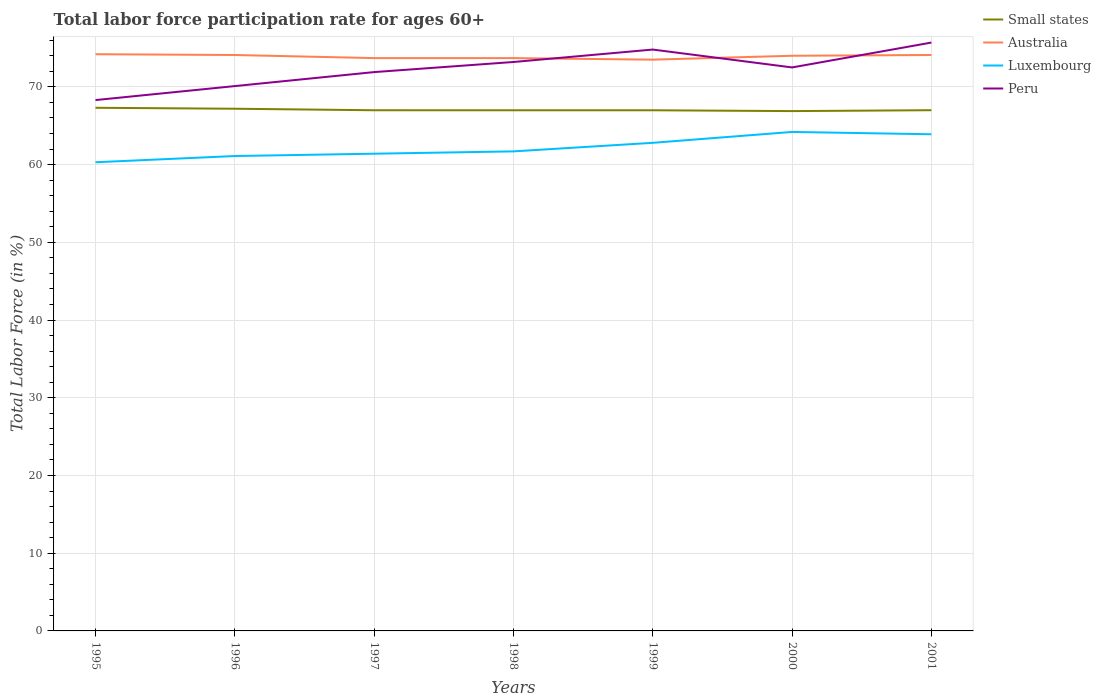Across all years, what is the maximum labor force participation rate in Luxembourg?
Give a very brief answer. 60.3. What is the total labor force participation rate in Peru in the graph?
Make the answer very short. -0.9. What is the difference between the highest and the second highest labor force participation rate in Luxembourg?
Offer a very short reply. 3.9. What is the difference between the highest and the lowest labor force participation rate in Small states?
Offer a very short reply. 2. Is the labor force participation rate in Luxembourg strictly greater than the labor force participation rate in Peru over the years?
Your answer should be compact. Yes. How many lines are there?
Keep it short and to the point. 4. How many years are there in the graph?
Offer a very short reply. 7. Are the values on the major ticks of Y-axis written in scientific E-notation?
Your answer should be compact. No. Does the graph contain any zero values?
Your answer should be compact. No. Does the graph contain grids?
Your answer should be compact. Yes. Where does the legend appear in the graph?
Make the answer very short. Top right. How many legend labels are there?
Your answer should be very brief. 4. How are the legend labels stacked?
Give a very brief answer. Vertical. What is the title of the graph?
Offer a terse response. Total labor force participation rate for ages 60+. Does "Paraguay" appear as one of the legend labels in the graph?
Your response must be concise. No. What is the Total Labor Force (in %) of Small states in 1995?
Give a very brief answer. 67.31. What is the Total Labor Force (in %) of Australia in 1995?
Your answer should be very brief. 74.2. What is the Total Labor Force (in %) in Luxembourg in 1995?
Give a very brief answer. 60.3. What is the Total Labor Force (in %) of Peru in 1995?
Ensure brevity in your answer.  68.3. What is the Total Labor Force (in %) of Small states in 1996?
Offer a very short reply. 67.19. What is the Total Labor Force (in %) in Australia in 1996?
Offer a terse response. 74.1. What is the Total Labor Force (in %) in Luxembourg in 1996?
Your answer should be very brief. 61.1. What is the Total Labor Force (in %) in Peru in 1996?
Keep it short and to the point. 70.1. What is the Total Labor Force (in %) of Small states in 1997?
Ensure brevity in your answer.  66.99. What is the Total Labor Force (in %) in Australia in 1997?
Keep it short and to the point. 73.7. What is the Total Labor Force (in %) of Luxembourg in 1997?
Give a very brief answer. 61.4. What is the Total Labor Force (in %) in Peru in 1997?
Keep it short and to the point. 71.9. What is the Total Labor Force (in %) of Small states in 1998?
Provide a short and direct response. 66.99. What is the Total Labor Force (in %) in Australia in 1998?
Your response must be concise. 73.7. What is the Total Labor Force (in %) in Luxembourg in 1998?
Ensure brevity in your answer.  61.7. What is the Total Labor Force (in %) in Peru in 1998?
Offer a terse response. 73.2. What is the Total Labor Force (in %) of Small states in 1999?
Make the answer very short. 66.99. What is the Total Labor Force (in %) of Australia in 1999?
Your answer should be very brief. 73.5. What is the Total Labor Force (in %) in Luxembourg in 1999?
Give a very brief answer. 62.8. What is the Total Labor Force (in %) of Peru in 1999?
Make the answer very short. 74.8. What is the Total Labor Force (in %) of Small states in 2000?
Ensure brevity in your answer.  66.88. What is the Total Labor Force (in %) of Luxembourg in 2000?
Give a very brief answer. 64.2. What is the Total Labor Force (in %) of Peru in 2000?
Make the answer very short. 72.5. What is the Total Labor Force (in %) of Small states in 2001?
Your answer should be compact. 67. What is the Total Labor Force (in %) in Australia in 2001?
Your answer should be very brief. 74.1. What is the Total Labor Force (in %) of Luxembourg in 2001?
Your response must be concise. 63.9. What is the Total Labor Force (in %) of Peru in 2001?
Provide a succinct answer. 75.7. Across all years, what is the maximum Total Labor Force (in %) of Small states?
Make the answer very short. 67.31. Across all years, what is the maximum Total Labor Force (in %) in Australia?
Your response must be concise. 74.2. Across all years, what is the maximum Total Labor Force (in %) of Luxembourg?
Ensure brevity in your answer.  64.2. Across all years, what is the maximum Total Labor Force (in %) in Peru?
Give a very brief answer. 75.7. Across all years, what is the minimum Total Labor Force (in %) in Small states?
Ensure brevity in your answer.  66.88. Across all years, what is the minimum Total Labor Force (in %) of Australia?
Your answer should be compact. 73.5. Across all years, what is the minimum Total Labor Force (in %) in Luxembourg?
Offer a terse response. 60.3. Across all years, what is the minimum Total Labor Force (in %) in Peru?
Offer a terse response. 68.3. What is the total Total Labor Force (in %) in Small states in the graph?
Make the answer very short. 469.34. What is the total Total Labor Force (in %) of Australia in the graph?
Provide a succinct answer. 517.3. What is the total Total Labor Force (in %) of Luxembourg in the graph?
Offer a very short reply. 435.4. What is the total Total Labor Force (in %) of Peru in the graph?
Provide a succinct answer. 506.5. What is the difference between the Total Labor Force (in %) in Small states in 1995 and that in 1996?
Offer a terse response. 0.12. What is the difference between the Total Labor Force (in %) of Australia in 1995 and that in 1996?
Provide a succinct answer. 0.1. What is the difference between the Total Labor Force (in %) in Luxembourg in 1995 and that in 1996?
Offer a terse response. -0.8. What is the difference between the Total Labor Force (in %) in Peru in 1995 and that in 1996?
Provide a succinct answer. -1.8. What is the difference between the Total Labor Force (in %) of Small states in 1995 and that in 1997?
Provide a short and direct response. 0.32. What is the difference between the Total Labor Force (in %) of Australia in 1995 and that in 1997?
Offer a terse response. 0.5. What is the difference between the Total Labor Force (in %) of Luxembourg in 1995 and that in 1997?
Your answer should be very brief. -1.1. What is the difference between the Total Labor Force (in %) in Small states in 1995 and that in 1998?
Your response must be concise. 0.32. What is the difference between the Total Labor Force (in %) of Small states in 1995 and that in 1999?
Your response must be concise. 0.32. What is the difference between the Total Labor Force (in %) of Luxembourg in 1995 and that in 1999?
Ensure brevity in your answer.  -2.5. What is the difference between the Total Labor Force (in %) in Small states in 1995 and that in 2000?
Ensure brevity in your answer.  0.43. What is the difference between the Total Labor Force (in %) in Luxembourg in 1995 and that in 2000?
Give a very brief answer. -3.9. What is the difference between the Total Labor Force (in %) in Small states in 1995 and that in 2001?
Your answer should be compact. 0.31. What is the difference between the Total Labor Force (in %) of Australia in 1995 and that in 2001?
Make the answer very short. 0.1. What is the difference between the Total Labor Force (in %) in Luxembourg in 1995 and that in 2001?
Give a very brief answer. -3.6. What is the difference between the Total Labor Force (in %) of Small states in 1996 and that in 1997?
Make the answer very short. 0.2. What is the difference between the Total Labor Force (in %) of Luxembourg in 1996 and that in 1997?
Keep it short and to the point. -0.3. What is the difference between the Total Labor Force (in %) of Peru in 1996 and that in 1997?
Your response must be concise. -1.8. What is the difference between the Total Labor Force (in %) in Small states in 1996 and that in 1998?
Your answer should be very brief. 0.2. What is the difference between the Total Labor Force (in %) in Peru in 1996 and that in 1998?
Offer a terse response. -3.1. What is the difference between the Total Labor Force (in %) of Small states in 1996 and that in 1999?
Your response must be concise. 0.2. What is the difference between the Total Labor Force (in %) in Small states in 1996 and that in 2000?
Give a very brief answer. 0.31. What is the difference between the Total Labor Force (in %) in Small states in 1996 and that in 2001?
Keep it short and to the point. 0.19. What is the difference between the Total Labor Force (in %) of Luxembourg in 1996 and that in 2001?
Keep it short and to the point. -2.8. What is the difference between the Total Labor Force (in %) in Small states in 1997 and that in 1998?
Your response must be concise. 0. What is the difference between the Total Labor Force (in %) of Australia in 1997 and that in 1998?
Ensure brevity in your answer.  0. What is the difference between the Total Labor Force (in %) of Luxembourg in 1997 and that in 1998?
Offer a very short reply. -0.3. What is the difference between the Total Labor Force (in %) of Small states in 1997 and that in 1999?
Make the answer very short. 0. What is the difference between the Total Labor Force (in %) of Australia in 1997 and that in 1999?
Provide a short and direct response. 0.2. What is the difference between the Total Labor Force (in %) in Luxembourg in 1997 and that in 1999?
Offer a terse response. -1.4. What is the difference between the Total Labor Force (in %) in Small states in 1997 and that in 2000?
Your answer should be compact. 0.11. What is the difference between the Total Labor Force (in %) in Australia in 1997 and that in 2000?
Offer a terse response. -0.3. What is the difference between the Total Labor Force (in %) of Peru in 1997 and that in 2000?
Give a very brief answer. -0.6. What is the difference between the Total Labor Force (in %) of Small states in 1997 and that in 2001?
Provide a short and direct response. -0.01. What is the difference between the Total Labor Force (in %) in Australia in 1997 and that in 2001?
Ensure brevity in your answer.  -0.4. What is the difference between the Total Labor Force (in %) in Peru in 1997 and that in 2001?
Your answer should be very brief. -3.8. What is the difference between the Total Labor Force (in %) in Small states in 1998 and that in 1999?
Give a very brief answer. 0. What is the difference between the Total Labor Force (in %) of Luxembourg in 1998 and that in 1999?
Your answer should be compact. -1.1. What is the difference between the Total Labor Force (in %) in Small states in 1998 and that in 2000?
Your answer should be compact. 0.11. What is the difference between the Total Labor Force (in %) of Peru in 1998 and that in 2000?
Provide a succinct answer. 0.7. What is the difference between the Total Labor Force (in %) of Small states in 1998 and that in 2001?
Ensure brevity in your answer.  -0.01. What is the difference between the Total Labor Force (in %) of Australia in 1998 and that in 2001?
Offer a very short reply. -0.4. What is the difference between the Total Labor Force (in %) in Small states in 1999 and that in 2000?
Ensure brevity in your answer.  0.11. What is the difference between the Total Labor Force (in %) in Peru in 1999 and that in 2000?
Your response must be concise. 2.3. What is the difference between the Total Labor Force (in %) in Small states in 1999 and that in 2001?
Make the answer very short. -0.01. What is the difference between the Total Labor Force (in %) in Australia in 1999 and that in 2001?
Offer a very short reply. -0.6. What is the difference between the Total Labor Force (in %) in Luxembourg in 1999 and that in 2001?
Offer a very short reply. -1.1. What is the difference between the Total Labor Force (in %) in Small states in 2000 and that in 2001?
Keep it short and to the point. -0.12. What is the difference between the Total Labor Force (in %) of Luxembourg in 2000 and that in 2001?
Keep it short and to the point. 0.3. What is the difference between the Total Labor Force (in %) of Small states in 1995 and the Total Labor Force (in %) of Australia in 1996?
Ensure brevity in your answer.  -6.79. What is the difference between the Total Labor Force (in %) in Small states in 1995 and the Total Labor Force (in %) in Luxembourg in 1996?
Provide a succinct answer. 6.21. What is the difference between the Total Labor Force (in %) in Small states in 1995 and the Total Labor Force (in %) in Peru in 1996?
Offer a very short reply. -2.79. What is the difference between the Total Labor Force (in %) in Australia in 1995 and the Total Labor Force (in %) in Peru in 1996?
Your answer should be very brief. 4.1. What is the difference between the Total Labor Force (in %) of Small states in 1995 and the Total Labor Force (in %) of Australia in 1997?
Your response must be concise. -6.39. What is the difference between the Total Labor Force (in %) of Small states in 1995 and the Total Labor Force (in %) of Luxembourg in 1997?
Your response must be concise. 5.91. What is the difference between the Total Labor Force (in %) in Small states in 1995 and the Total Labor Force (in %) in Peru in 1997?
Your response must be concise. -4.59. What is the difference between the Total Labor Force (in %) in Australia in 1995 and the Total Labor Force (in %) in Peru in 1997?
Your response must be concise. 2.3. What is the difference between the Total Labor Force (in %) in Small states in 1995 and the Total Labor Force (in %) in Australia in 1998?
Keep it short and to the point. -6.39. What is the difference between the Total Labor Force (in %) in Small states in 1995 and the Total Labor Force (in %) in Luxembourg in 1998?
Your response must be concise. 5.61. What is the difference between the Total Labor Force (in %) in Small states in 1995 and the Total Labor Force (in %) in Peru in 1998?
Keep it short and to the point. -5.89. What is the difference between the Total Labor Force (in %) in Australia in 1995 and the Total Labor Force (in %) in Luxembourg in 1998?
Provide a short and direct response. 12.5. What is the difference between the Total Labor Force (in %) of Small states in 1995 and the Total Labor Force (in %) of Australia in 1999?
Provide a succinct answer. -6.19. What is the difference between the Total Labor Force (in %) in Small states in 1995 and the Total Labor Force (in %) in Luxembourg in 1999?
Make the answer very short. 4.51. What is the difference between the Total Labor Force (in %) in Small states in 1995 and the Total Labor Force (in %) in Peru in 1999?
Offer a terse response. -7.49. What is the difference between the Total Labor Force (in %) of Australia in 1995 and the Total Labor Force (in %) of Luxembourg in 1999?
Give a very brief answer. 11.4. What is the difference between the Total Labor Force (in %) in Australia in 1995 and the Total Labor Force (in %) in Peru in 1999?
Offer a very short reply. -0.6. What is the difference between the Total Labor Force (in %) of Small states in 1995 and the Total Labor Force (in %) of Australia in 2000?
Provide a short and direct response. -6.69. What is the difference between the Total Labor Force (in %) in Small states in 1995 and the Total Labor Force (in %) in Luxembourg in 2000?
Make the answer very short. 3.11. What is the difference between the Total Labor Force (in %) in Small states in 1995 and the Total Labor Force (in %) in Peru in 2000?
Make the answer very short. -5.19. What is the difference between the Total Labor Force (in %) of Australia in 1995 and the Total Labor Force (in %) of Luxembourg in 2000?
Your answer should be very brief. 10. What is the difference between the Total Labor Force (in %) in Australia in 1995 and the Total Labor Force (in %) in Peru in 2000?
Offer a terse response. 1.7. What is the difference between the Total Labor Force (in %) in Small states in 1995 and the Total Labor Force (in %) in Australia in 2001?
Provide a succinct answer. -6.79. What is the difference between the Total Labor Force (in %) in Small states in 1995 and the Total Labor Force (in %) in Luxembourg in 2001?
Provide a succinct answer. 3.41. What is the difference between the Total Labor Force (in %) in Small states in 1995 and the Total Labor Force (in %) in Peru in 2001?
Your answer should be compact. -8.39. What is the difference between the Total Labor Force (in %) in Luxembourg in 1995 and the Total Labor Force (in %) in Peru in 2001?
Keep it short and to the point. -15.4. What is the difference between the Total Labor Force (in %) in Small states in 1996 and the Total Labor Force (in %) in Australia in 1997?
Your answer should be compact. -6.51. What is the difference between the Total Labor Force (in %) in Small states in 1996 and the Total Labor Force (in %) in Luxembourg in 1997?
Provide a succinct answer. 5.79. What is the difference between the Total Labor Force (in %) of Small states in 1996 and the Total Labor Force (in %) of Peru in 1997?
Your response must be concise. -4.71. What is the difference between the Total Labor Force (in %) in Australia in 1996 and the Total Labor Force (in %) in Luxembourg in 1997?
Keep it short and to the point. 12.7. What is the difference between the Total Labor Force (in %) of Luxembourg in 1996 and the Total Labor Force (in %) of Peru in 1997?
Offer a very short reply. -10.8. What is the difference between the Total Labor Force (in %) in Small states in 1996 and the Total Labor Force (in %) in Australia in 1998?
Your answer should be compact. -6.51. What is the difference between the Total Labor Force (in %) in Small states in 1996 and the Total Labor Force (in %) in Luxembourg in 1998?
Offer a terse response. 5.49. What is the difference between the Total Labor Force (in %) of Small states in 1996 and the Total Labor Force (in %) of Peru in 1998?
Your answer should be very brief. -6.01. What is the difference between the Total Labor Force (in %) of Australia in 1996 and the Total Labor Force (in %) of Luxembourg in 1998?
Keep it short and to the point. 12.4. What is the difference between the Total Labor Force (in %) in Australia in 1996 and the Total Labor Force (in %) in Peru in 1998?
Make the answer very short. 0.9. What is the difference between the Total Labor Force (in %) of Luxembourg in 1996 and the Total Labor Force (in %) of Peru in 1998?
Your answer should be compact. -12.1. What is the difference between the Total Labor Force (in %) in Small states in 1996 and the Total Labor Force (in %) in Australia in 1999?
Keep it short and to the point. -6.31. What is the difference between the Total Labor Force (in %) of Small states in 1996 and the Total Labor Force (in %) of Luxembourg in 1999?
Provide a succinct answer. 4.39. What is the difference between the Total Labor Force (in %) in Small states in 1996 and the Total Labor Force (in %) in Peru in 1999?
Make the answer very short. -7.61. What is the difference between the Total Labor Force (in %) in Australia in 1996 and the Total Labor Force (in %) in Luxembourg in 1999?
Give a very brief answer. 11.3. What is the difference between the Total Labor Force (in %) of Australia in 1996 and the Total Labor Force (in %) of Peru in 1999?
Offer a terse response. -0.7. What is the difference between the Total Labor Force (in %) of Luxembourg in 1996 and the Total Labor Force (in %) of Peru in 1999?
Keep it short and to the point. -13.7. What is the difference between the Total Labor Force (in %) in Small states in 1996 and the Total Labor Force (in %) in Australia in 2000?
Offer a very short reply. -6.81. What is the difference between the Total Labor Force (in %) in Small states in 1996 and the Total Labor Force (in %) in Luxembourg in 2000?
Give a very brief answer. 2.99. What is the difference between the Total Labor Force (in %) in Small states in 1996 and the Total Labor Force (in %) in Peru in 2000?
Make the answer very short. -5.31. What is the difference between the Total Labor Force (in %) in Australia in 1996 and the Total Labor Force (in %) in Peru in 2000?
Offer a terse response. 1.6. What is the difference between the Total Labor Force (in %) in Luxembourg in 1996 and the Total Labor Force (in %) in Peru in 2000?
Keep it short and to the point. -11.4. What is the difference between the Total Labor Force (in %) of Small states in 1996 and the Total Labor Force (in %) of Australia in 2001?
Offer a terse response. -6.91. What is the difference between the Total Labor Force (in %) of Small states in 1996 and the Total Labor Force (in %) of Luxembourg in 2001?
Make the answer very short. 3.29. What is the difference between the Total Labor Force (in %) in Small states in 1996 and the Total Labor Force (in %) in Peru in 2001?
Your response must be concise. -8.51. What is the difference between the Total Labor Force (in %) of Australia in 1996 and the Total Labor Force (in %) of Peru in 2001?
Provide a succinct answer. -1.6. What is the difference between the Total Labor Force (in %) in Luxembourg in 1996 and the Total Labor Force (in %) in Peru in 2001?
Ensure brevity in your answer.  -14.6. What is the difference between the Total Labor Force (in %) of Small states in 1997 and the Total Labor Force (in %) of Australia in 1998?
Provide a short and direct response. -6.71. What is the difference between the Total Labor Force (in %) in Small states in 1997 and the Total Labor Force (in %) in Luxembourg in 1998?
Your answer should be compact. 5.29. What is the difference between the Total Labor Force (in %) of Small states in 1997 and the Total Labor Force (in %) of Peru in 1998?
Offer a very short reply. -6.21. What is the difference between the Total Labor Force (in %) in Luxembourg in 1997 and the Total Labor Force (in %) in Peru in 1998?
Give a very brief answer. -11.8. What is the difference between the Total Labor Force (in %) in Small states in 1997 and the Total Labor Force (in %) in Australia in 1999?
Your response must be concise. -6.51. What is the difference between the Total Labor Force (in %) of Small states in 1997 and the Total Labor Force (in %) of Luxembourg in 1999?
Offer a terse response. 4.19. What is the difference between the Total Labor Force (in %) in Small states in 1997 and the Total Labor Force (in %) in Peru in 1999?
Make the answer very short. -7.81. What is the difference between the Total Labor Force (in %) of Australia in 1997 and the Total Labor Force (in %) of Luxembourg in 1999?
Provide a short and direct response. 10.9. What is the difference between the Total Labor Force (in %) of Small states in 1997 and the Total Labor Force (in %) of Australia in 2000?
Give a very brief answer. -7.01. What is the difference between the Total Labor Force (in %) in Small states in 1997 and the Total Labor Force (in %) in Luxembourg in 2000?
Give a very brief answer. 2.79. What is the difference between the Total Labor Force (in %) of Small states in 1997 and the Total Labor Force (in %) of Peru in 2000?
Offer a very short reply. -5.51. What is the difference between the Total Labor Force (in %) of Australia in 1997 and the Total Labor Force (in %) of Luxembourg in 2000?
Keep it short and to the point. 9.5. What is the difference between the Total Labor Force (in %) in Australia in 1997 and the Total Labor Force (in %) in Peru in 2000?
Provide a succinct answer. 1.2. What is the difference between the Total Labor Force (in %) in Small states in 1997 and the Total Labor Force (in %) in Australia in 2001?
Your answer should be compact. -7.11. What is the difference between the Total Labor Force (in %) of Small states in 1997 and the Total Labor Force (in %) of Luxembourg in 2001?
Provide a succinct answer. 3.09. What is the difference between the Total Labor Force (in %) in Small states in 1997 and the Total Labor Force (in %) in Peru in 2001?
Your answer should be very brief. -8.71. What is the difference between the Total Labor Force (in %) in Australia in 1997 and the Total Labor Force (in %) in Peru in 2001?
Keep it short and to the point. -2. What is the difference between the Total Labor Force (in %) in Luxembourg in 1997 and the Total Labor Force (in %) in Peru in 2001?
Your answer should be compact. -14.3. What is the difference between the Total Labor Force (in %) of Small states in 1998 and the Total Labor Force (in %) of Australia in 1999?
Offer a very short reply. -6.51. What is the difference between the Total Labor Force (in %) of Small states in 1998 and the Total Labor Force (in %) of Luxembourg in 1999?
Make the answer very short. 4.19. What is the difference between the Total Labor Force (in %) of Small states in 1998 and the Total Labor Force (in %) of Peru in 1999?
Your answer should be compact. -7.81. What is the difference between the Total Labor Force (in %) in Australia in 1998 and the Total Labor Force (in %) in Peru in 1999?
Offer a terse response. -1.1. What is the difference between the Total Labor Force (in %) of Luxembourg in 1998 and the Total Labor Force (in %) of Peru in 1999?
Your answer should be very brief. -13.1. What is the difference between the Total Labor Force (in %) in Small states in 1998 and the Total Labor Force (in %) in Australia in 2000?
Make the answer very short. -7.01. What is the difference between the Total Labor Force (in %) in Small states in 1998 and the Total Labor Force (in %) in Luxembourg in 2000?
Make the answer very short. 2.79. What is the difference between the Total Labor Force (in %) of Small states in 1998 and the Total Labor Force (in %) of Peru in 2000?
Your answer should be very brief. -5.51. What is the difference between the Total Labor Force (in %) in Australia in 1998 and the Total Labor Force (in %) in Luxembourg in 2000?
Your answer should be very brief. 9.5. What is the difference between the Total Labor Force (in %) in Australia in 1998 and the Total Labor Force (in %) in Peru in 2000?
Your response must be concise. 1.2. What is the difference between the Total Labor Force (in %) in Small states in 1998 and the Total Labor Force (in %) in Australia in 2001?
Keep it short and to the point. -7.11. What is the difference between the Total Labor Force (in %) in Small states in 1998 and the Total Labor Force (in %) in Luxembourg in 2001?
Provide a short and direct response. 3.09. What is the difference between the Total Labor Force (in %) of Small states in 1998 and the Total Labor Force (in %) of Peru in 2001?
Make the answer very short. -8.71. What is the difference between the Total Labor Force (in %) in Australia in 1998 and the Total Labor Force (in %) in Luxembourg in 2001?
Give a very brief answer. 9.8. What is the difference between the Total Labor Force (in %) in Small states in 1999 and the Total Labor Force (in %) in Australia in 2000?
Provide a succinct answer. -7.01. What is the difference between the Total Labor Force (in %) of Small states in 1999 and the Total Labor Force (in %) of Luxembourg in 2000?
Offer a terse response. 2.79. What is the difference between the Total Labor Force (in %) in Small states in 1999 and the Total Labor Force (in %) in Peru in 2000?
Make the answer very short. -5.51. What is the difference between the Total Labor Force (in %) in Australia in 1999 and the Total Labor Force (in %) in Peru in 2000?
Your answer should be compact. 1. What is the difference between the Total Labor Force (in %) of Small states in 1999 and the Total Labor Force (in %) of Australia in 2001?
Make the answer very short. -7.11. What is the difference between the Total Labor Force (in %) in Small states in 1999 and the Total Labor Force (in %) in Luxembourg in 2001?
Your answer should be compact. 3.09. What is the difference between the Total Labor Force (in %) of Small states in 1999 and the Total Labor Force (in %) of Peru in 2001?
Offer a terse response. -8.71. What is the difference between the Total Labor Force (in %) of Australia in 1999 and the Total Labor Force (in %) of Peru in 2001?
Offer a terse response. -2.2. What is the difference between the Total Labor Force (in %) of Small states in 2000 and the Total Labor Force (in %) of Australia in 2001?
Keep it short and to the point. -7.22. What is the difference between the Total Labor Force (in %) in Small states in 2000 and the Total Labor Force (in %) in Luxembourg in 2001?
Your answer should be compact. 2.98. What is the difference between the Total Labor Force (in %) of Small states in 2000 and the Total Labor Force (in %) of Peru in 2001?
Offer a very short reply. -8.82. What is the difference between the Total Labor Force (in %) in Australia in 2000 and the Total Labor Force (in %) in Luxembourg in 2001?
Provide a short and direct response. 10.1. What is the difference between the Total Labor Force (in %) of Australia in 2000 and the Total Labor Force (in %) of Peru in 2001?
Ensure brevity in your answer.  -1.7. What is the average Total Labor Force (in %) in Small states per year?
Offer a terse response. 67.05. What is the average Total Labor Force (in %) in Australia per year?
Provide a short and direct response. 73.9. What is the average Total Labor Force (in %) of Luxembourg per year?
Your response must be concise. 62.2. What is the average Total Labor Force (in %) in Peru per year?
Offer a very short reply. 72.36. In the year 1995, what is the difference between the Total Labor Force (in %) of Small states and Total Labor Force (in %) of Australia?
Your response must be concise. -6.89. In the year 1995, what is the difference between the Total Labor Force (in %) of Small states and Total Labor Force (in %) of Luxembourg?
Make the answer very short. 7.01. In the year 1995, what is the difference between the Total Labor Force (in %) of Small states and Total Labor Force (in %) of Peru?
Your answer should be very brief. -0.99. In the year 1995, what is the difference between the Total Labor Force (in %) in Australia and Total Labor Force (in %) in Luxembourg?
Provide a succinct answer. 13.9. In the year 1995, what is the difference between the Total Labor Force (in %) of Australia and Total Labor Force (in %) of Peru?
Provide a succinct answer. 5.9. In the year 1996, what is the difference between the Total Labor Force (in %) of Small states and Total Labor Force (in %) of Australia?
Keep it short and to the point. -6.91. In the year 1996, what is the difference between the Total Labor Force (in %) in Small states and Total Labor Force (in %) in Luxembourg?
Offer a very short reply. 6.09. In the year 1996, what is the difference between the Total Labor Force (in %) in Small states and Total Labor Force (in %) in Peru?
Your response must be concise. -2.91. In the year 1997, what is the difference between the Total Labor Force (in %) in Small states and Total Labor Force (in %) in Australia?
Your answer should be compact. -6.71. In the year 1997, what is the difference between the Total Labor Force (in %) in Small states and Total Labor Force (in %) in Luxembourg?
Provide a short and direct response. 5.59. In the year 1997, what is the difference between the Total Labor Force (in %) in Small states and Total Labor Force (in %) in Peru?
Ensure brevity in your answer.  -4.91. In the year 1997, what is the difference between the Total Labor Force (in %) in Australia and Total Labor Force (in %) in Peru?
Offer a very short reply. 1.8. In the year 1997, what is the difference between the Total Labor Force (in %) of Luxembourg and Total Labor Force (in %) of Peru?
Provide a succinct answer. -10.5. In the year 1998, what is the difference between the Total Labor Force (in %) in Small states and Total Labor Force (in %) in Australia?
Keep it short and to the point. -6.71. In the year 1998, what is the difference between the Total Labor Force (in %) in Small states and Total Labor Force (in %) in Luxembourg?
Provide a succinct answer. 5.29. In the year 1998, what is the difference between the Total Labor Force (in %) of Small states and Total Labor Force (in %) of Peru?
Your answer should be compact. -6.21. In the year 1998, what is the difference between the Total Labor Force (in %) of Australia and Total Labor Force (in %) of Peru?
Keep it short and to the point. 0.5. In the year 1999, what is the difference between the Total Labor Force (in %) of Small states and Total Labor Force (in %) of Australia?
Keep it short and to the point. -6.51. In the year 1999, what is the difference between the Total Labor Force (in %) in Small states and Total Labor Force (in %) in Luxembourg?
Keep it short and to the point. 4.19. In the year 1999, what is the difference between the Total Labor Force (in %) of Small states and Total Labor Force (in %) of Peru?
Make the answer very short. -7.81. In the year 1999, what is the difference between the Total Labor Force (in %) of Luxembourg and Total Labor Force (in %) of Peru?
Give a very brief answer. -12. In the year 2000, what is the difference between the Total Labor Force (in %) of Small states and Total Labor Force (in %) of Australia?
Offer a very short reply. -7.12. In the year 2000, what is the difference between the Total Labor Force (in %) of Small states and Total Labor Force (in %) of Luxembourg?
Your answer should be very brief. 2.68. In the year 2000, what is the difference between the Total Labor Force (in %) of Small states and Total Labor Force (in %) of Peru?
Offer a terse response. -5.62. In the year 2000, what is the difference between the Total Labor Force (in %) in Australia and Total Labor Force (in %) in Peru?
Your response must be concise. 1.5. In the year 2001, what is the difference between the Total Labor Force (in %) in Small states and Total Labor Force (in %) in Australia?
Your answer should be very brief. -7.1. In the year 2001, what is the difference between the Total Labor Force (in %) of Small states and Total Labor Force (in %) of Luxembourg?
Your answer should be very brief. 3.1. In the year 2001, what is the difference between the Total Labor Force (in %) in Small states and Total Labor Force (in %) in Peru?
Provide a short and direct response. -8.7. In the year 2001, what is the difference between the Total Labor Force (in %) in Australia and Total Labor Force (in %) in Luxembourg?
Provide a succinct answer. 10.2. What is the ratio of the Total Labor Force (in %) of Australia in 1995 to that in 1996?
Make the answer very short. 1. What is the ratio of the Total Labor Force (in %) in Luxembourg in 1995 to that in 1996?
Offer a terse response. 0.99. What is the ratio of the Total Labor Force (in %) in Peru in 1995 to that in 1996?
Provide a succinct answer. 0.97. What is the ratio of the Total Labor Force (in %) in Australia in 1995 to that in 1997?
Your answer should be compact. 1.01. What is the ratio of the Total Labor Force (in %) of Luxembourg in 1995 to that in 1997?
Give a very brief answer. 0.98. What is the ratio of the Total Labor Force (in %) in Peru in 1995 to that in 1997?
Provide a succinct answer. 0.95. What is the ratio of the Total Labor Force (in %) of Small states in 1995 to that in 1998?
Provide a short and direct response. 1. What is the ratio of the Total Labor Force (in %) in Australia in 1995 to that in 1998?
Provide a succinct answer. 1.01. What is the ratio of the Total Labor Force (in %) in Luxembourg in 1995 to that in 1998?
Keep it short and to the point. 0.98. What is the ratio of the Total Labor Force (in %) of Peru in 1995 to that in 1998?
Keep it short and to the point. 0.93. What is the ratio of the Total Labor Force (in %) in Australia in 1995 to that in 1999?
Your answer should be very brief. 1.01. What is the ratio of the Total Labor Force (in %) of Luxembourg in 1995 to that in 1999?
Ensure brevity in your answer.  0.96. What is the ratio of the Total Labor Force (in %) of Peru in 1995 to that in 1999?
Your response must be concise. 0.91. What is the ratio of the Total Labor Force (in %) of Small states in 1995 to that in 2000?
Your answer should be very brief. 1.01. What is the ratio of the Total Labor Force (in %) of Australia in 1995 to that in 2000?
Ensure brevity in your answer.  1. What is the ratio of the Total Labor Force (in %) in Luxembourg in 1995 to that in 2000?
Provide a short and direct response. 0.94. What is the ratio of the Total Labor Force (in %) of Peru in 1995 to that in 2000?
Offer a very short reply. 0.94. What is the ratio of the Total Labor Force (in %) of Australia in 1995 to that in 2001?
Offer a terse response. 1. What is the ratio of the Total Labor Force (in %) in Luxembourg in 1995 to that in 2001?
Your answer should be compact. 0.94. What is the ratio of the Total Labor Force (in %) of Peru in 1995 to that in 2001?
Ensure brevity in your answer.  0.9. What is the ratio of the Total Labor Force (in %) in Small states in 1996 to that in 1997?
Offer a terse response. 1. What is the ratio of the Total Labor Force (in %) of Australia in 1996 to that in 1997?
Give a very brief answer. 1.01. What is the ratio of the Total Labor Force (in %) in Peru in 1996 to that in 1997?
Your response must be concise. 0.97. What is the ratio of the Total Labor Force (in %) in Small states in 1996 to that in 1998?
Your answer should be compact. 1. What is the ratio of the Total Labor Force (in %) of Australia in 1996 to that in 1998?
Offer a very short reply. 1.01. What is the ratio of the Total Labor Force (in %) in Luxembourg in 1996 to that in 1998?
Ensure brevity in your answer.  0.99. What is the ratio of the Total Labor Force (in %) of Peru in 1996 to that in 1998?
Provide a succinct answer. 0.96. What is the ratio of the Total Labor Force (in %) of Australia in 1996 to that in 1999?
Your answer should be very brief. 1.01. What is the ratio of the Total Labor Force (in %) in Luxembourg in 1996 to that in 1999?
Your answer should be very brief. 0.97. What is the ratio of the Total Labor Force (in %) of Peru in 1996 to that in 1999?
Offer a very short reply. 0.94. What is the ratio of the Total Labor Force (in %) in Luxembourg in 1996 to that in 2000?
Keep it short and to the point. 0.95. What is the ratio of the Total Labor Force (in %) in Peru in 1996 to that in 2000?
Keep it short and to the point. 0.97. What is the ratio of the Total Labor Force (in %) of Australia in 1996 to that in 2001?
Offer a terse response. 1. What is the ratio of the Total Labor Force (in %) of Luxembourg in 1996 to that in 2001?
Offer a terse response. 0.96. What is the ratio of the Total Labor Force (in %) of Peru in 1996 to that in 2001?
Give a very brief answer. 0.93. What is the ratio of the Total Labor Force (in %) of Australia in 1997 to that in 1998?
Your answer should be compact. 1. What is the ratio of the Total Labor Force (in %) in Luxembourg in 1997 to that in 1998?
Make the answer very short. 1. What is the ratio of the Total Labor Force (in %) in Peru in 1997 to that in 1998?
Offer a very short reply. 0.98. What is the ratio of the Total Labor Force (in %) in Small states in 1997 to that in 1999?
Provide a short and direct response. 1. What is the ratio of the Total Labor Force (in %) of Australia in 1997 to that in 1999?
Keep it short and to the point. 1. What is the ratio of the Total Labor Force (in %) of Luxembourg in 1997 to that in 1999?
Your answer should be compact. 0.98. What is the ratio of the Total Labor Force (in %) in Peru in 1997 to that in 1999?
Give a very brief answer. 0.96. What is the ratio of the Total Labor Force (in %) in Luxembourg in 1997 to that in 2000?
Your response must be concise. 0.96. What is the ratio of the Total Labor Force (in %) in Peru in 1997 to that in 2000?
Keep it short and to the point. 0.99. What is the ratio of the Total Labor Force (in %) in Luxembourg in 1997 to that in 2001?
Your answer should be compact. 0.96. What is the ratio of the Total Labor Force (in %) of Peru in 1997 to that in 2001?
Offer a very short reply. 0.95. What is the ratio of the Total Labor Force (in %) in Small states in 1998 to that in 1999?
Provide a succinct answer. 1. What is the ratio of the Total Labor Force (in %) of Luxembourg in 1998 to that in 1999?
Offer a very short reply. 0.98. What is the ratio of the Total Labor Force (in %) of Peru in 1998 to that in 1999?
Your response must be concise. 0.98. What is the ratio of the Total Labor Force (in %) in Small states in 1998 to that in 2000?
Provide a succinct answer. 1. What is the ratio of the Total Labor Force (in %) in Luxembourg in 1998 to that in 2000?
Provide a succinct answer. 0.96. What is the ratio of the Total Labor Force (in %) in Peru in 1998 to that in 2000?
Keep it short and to the point. 1.01. What is the ratio of the Total Labor Force (in %) in Small states in 1998 to that in 2001?
Provide a succinct answer. 1. What is the ratio of the Total Labor Force (in %) in Luxembourg in 1998 to that in 2001?
Offer a very short reply. 0.97. What is the ratio of the Total Labor Force (in %) in Small states in 1999 to that in 2000?
Provide a succinct answer. 1. What is the ratio of the Total Labor Force (in %) in Australia in 1999 to that in 2000?
Give a very brief answer. 0.99. What is the ratio of the Total Labor Force (in %) of Luxembourg in 1999 to that in 2000?
Ensure brevity in your answer.  0.98. What is the ratio of the Total Labor Force (in %) in Peru in 1999 to that in 2000?
Provide a short and direct response. 1.03. What is the ratio of the Total Labor Force (in %) of Luxembourg in 1999 to that in 2001?
Ensure brevity in your answer.  0.98. What is the ratio of the Total Labor Force (in %) in Australia in 2000 to that in 2001?
Ensure brevity in your answer.  1. What is the ratio of the Total Labor Force (in %) of Luxembourg in 2000 to that in 2001?
Your response must be concise. 1. What is the ratio of the Total Labor Force (in %) in Peru in 2000 to that in 2001?
Your answer should be very brief. 0.96. What is the difference between the highest and the second highest Total Labor Force (in %) in Small states?
Your response must be concise. 0.12. What is the difference between the highest and the second highest Total Labor Force (in %) of Luxembourg?
Provide a succinct answer. 0.3. What is the difference between the highest and the lowest Total Labor Force (in %) in Small states?
Provide a short and direct response. 0.43. What is the difference between the highest and the lowest Total Labor Force (in %) in Australia?
Your answer should be very brief. 0.7. What is the difference between the highest and the lowest Total Labor Force (in %) of Luxembourg?
Ensure brevity in your answer.  3.9. 